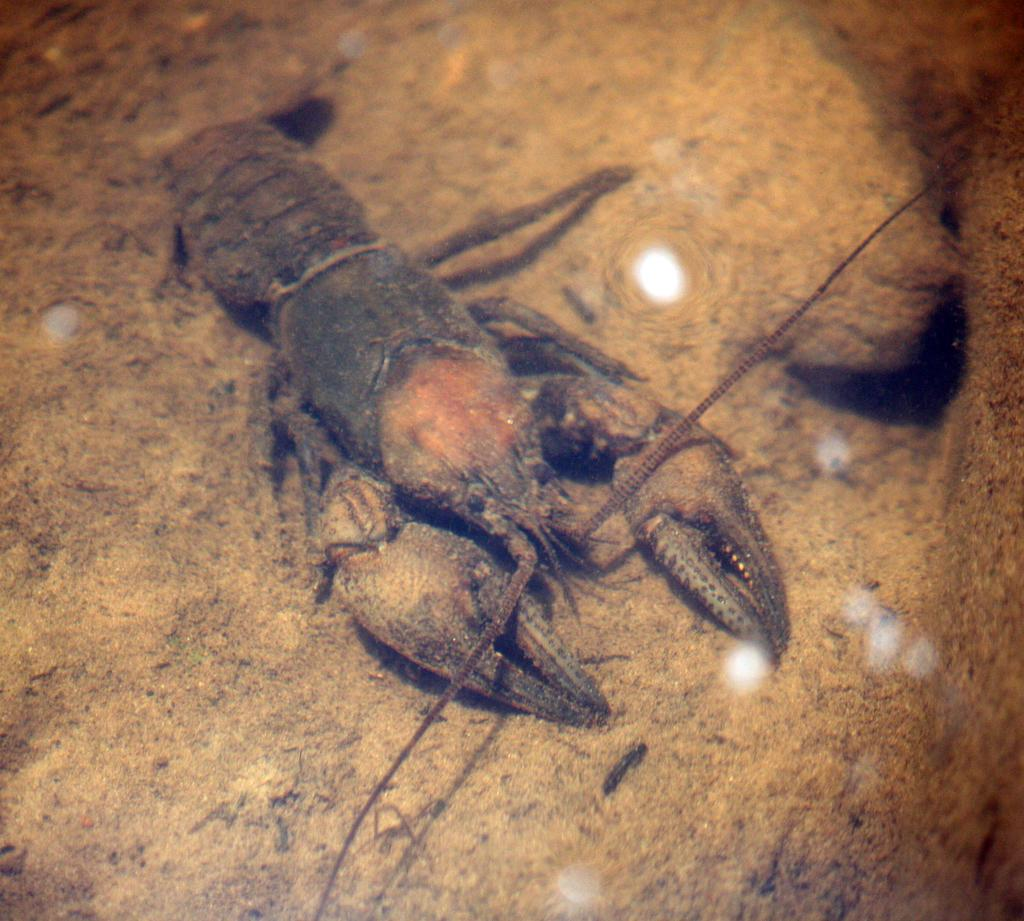What type of creature is in the picture? There is an animal in the picture, which looks like a scorpion. Where is the scorpion located in the image? The scorpion is on the ground. What type of grip does the scorpion have on the scene during the rainstorm? There is no mention of a rainstorm in the image, and the scorpion's grip is not visible or relevant to the description of the image. 